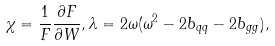Convert formula to latex. <formula><loc_0><loc_0><loc_500><loc_500>\chi = \frac { 1 } { F } \frac { \partial F } { \partial W } , \lambda = 2 \omega ( \omega ^ { 2 } - 2 b _ { q q } - 2 b _ { g g } ) ,</formula> 